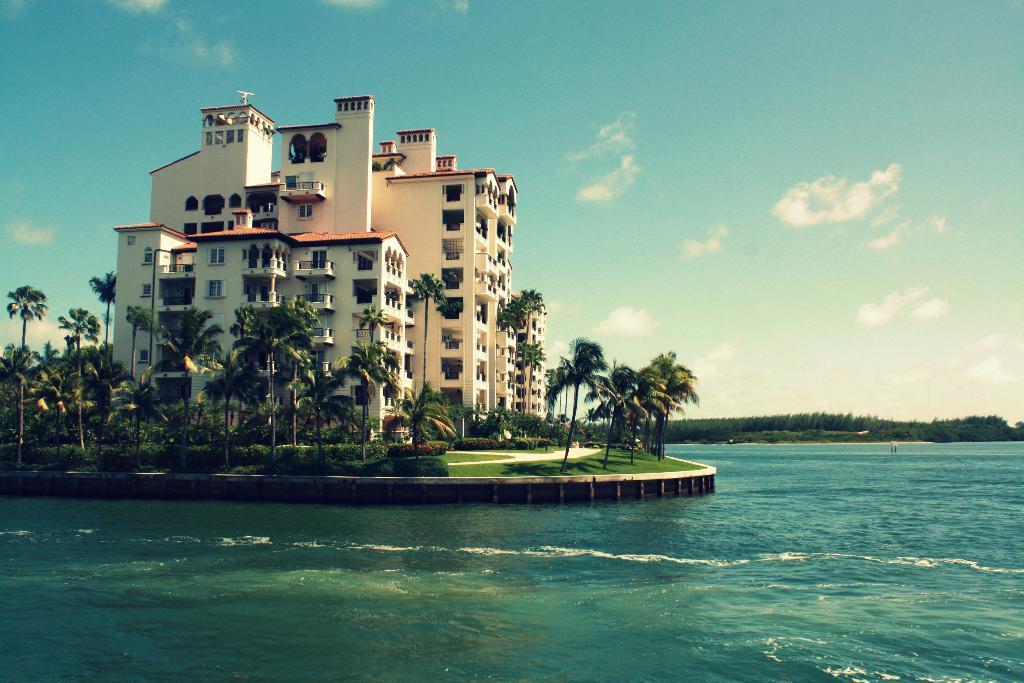Could you give a brief overview of what you see in this image? There is a surface of water as we can see at the bottom of this image, and there are some trees in the background. There is a building on the left side of this image, and there is a cloudy sky at the top of this image. 